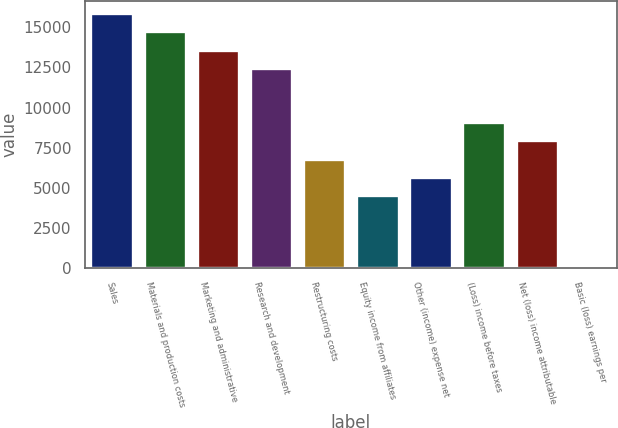<chart> <loc_0><loc_0><loc_500><loc_500><bar_chart><fcel>Sales<fcel>Materials and production costs<fcel>Marketing and administrative<fcel>Research and development<fcel>Restructuring costs<fcel>Equity income from affiliates<fcel>Other (income) expense net<fcel>(Loss) income before taxes<fcel>Net (loss) income attributable<fcel>Basic (loss) earnings per<nl><fcel>15884.4<fcel>14749.8<fcel>13615.2<fcel>12480.6<fcel>6807.72<fcel>4538.56<fcel>5673.14<fcel>9076.88<fcel>7942.3<fcel>0.24<nl></chart> 